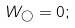Convert formula to latex. <formula><loc_0><loc_0><loc_500><loc_500>W _ { \mathcal { \gamma } } = 0 ;</formula> 